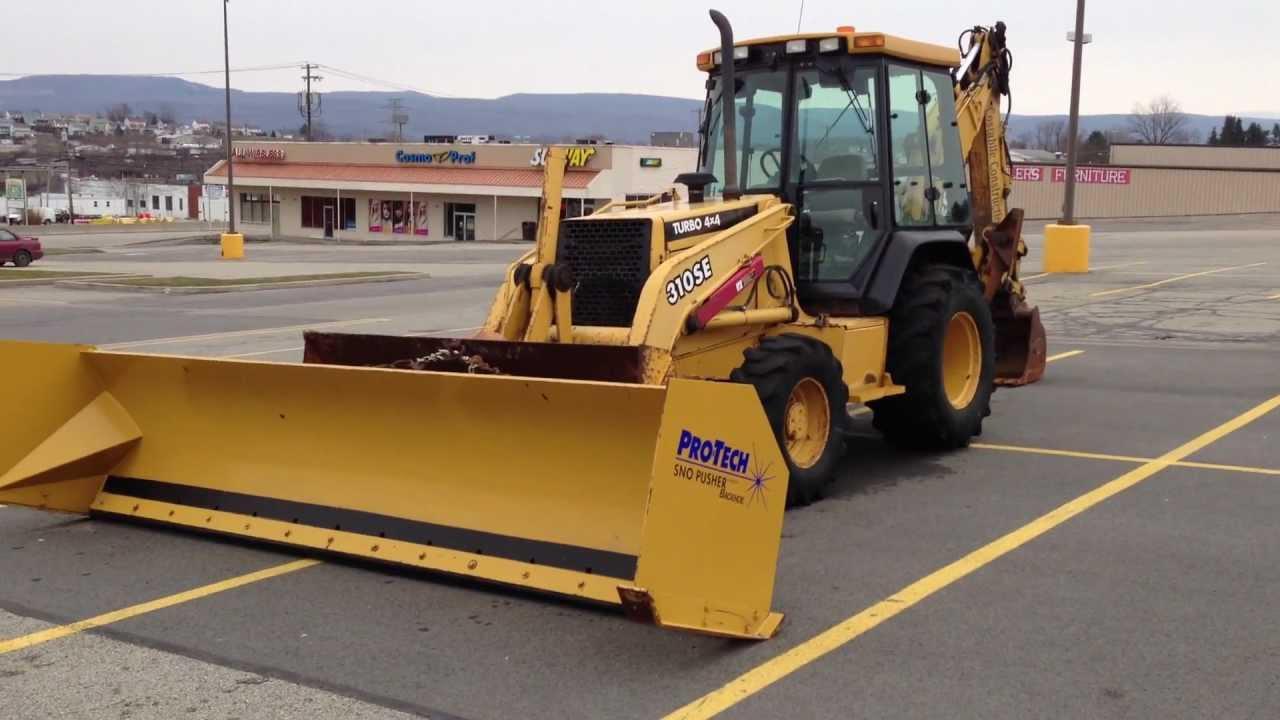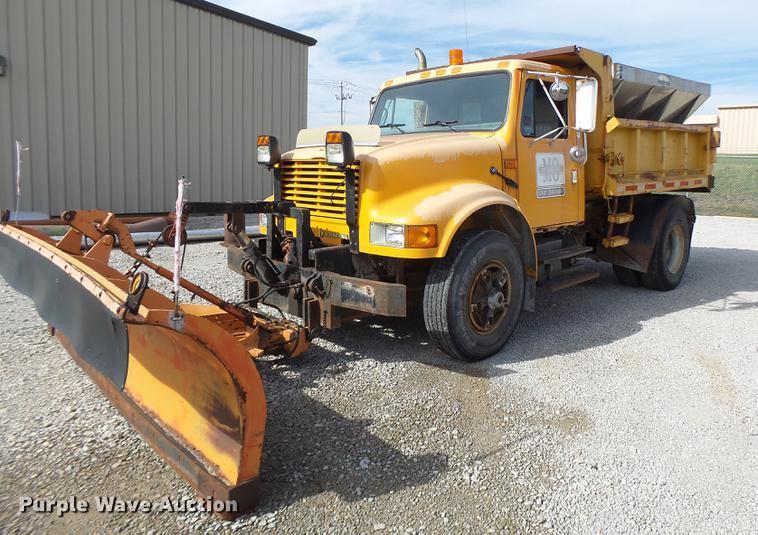The first image is the image on the left, the second image is the image on the right. Given the left and right images, does the statement "None of these trucks are pushing snow." hold true? Answer yes or no. Yes. The first image is the image on the left, the second image is the image on the right. Evaluate the accuracy of this statement regarding the images: "At least one snow plow is driving down the road clearing snow.". Is it true? Answer yes or no. No. 